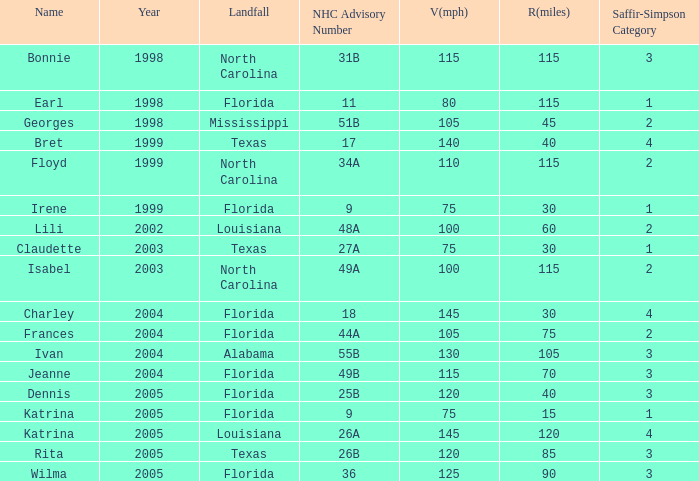Which landfall was in category 1 for Saffir-Simpson in 1999? Florida. 